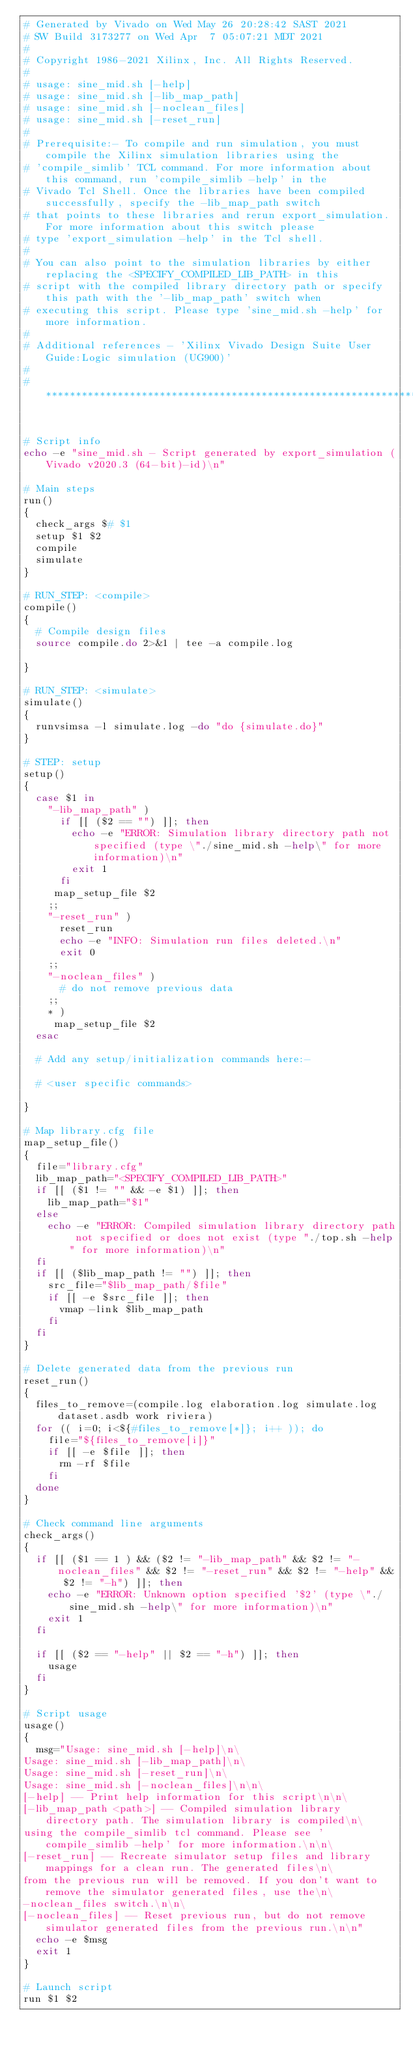Convert code to text. <code><loc_0><loc_0><loc_500><loc_500><_Bash_># Generated by Vivado on Wed May 26 20:28:42 SAST 2021
# SW Build 3173277 on Wed Apr  7 05:07:21 MDT 2021
#
# Copyright 1986-2021 Xilinx, Inc. All Rights Reserved. 
#
# usage: sine_mid.sh [-help]
# usage: sine_mid.sh [-lib_map_path]
# usage: sine_mid.sh [-noclean_files]
# usage: sine_mid.sh [-reset_run]
#
# Prerequisite:- To compile and run simulation, you must compile the Xilinx simulation libraries using the
# 'compile_simlib' TCL command. For more information about this command, run 'compile_simlib -help' in the
# Vivado Tcl Shell. Once the libraries have been compiled successfully, specify the -lib_map_path switch
# that points to these libraries and rerun export_simulation. For more information about this switch please
# type 'export_simulation -help' in the Tcl shell.
#
# You can also point to the simulation libraries by either replacing the <SPECIFY_COMPILED_LIB_PATH> in this
# script with the compiled library directory path or specify this path with the '-lib_map_path' switch when
# executing this script. Please type 'sine_mid.sh -help' for more information.
#
# Additional references - 'Xilinx Vivado Design Suite User Guide:Logic simulation (UG900)'
#
#*********************************************************************************************************


# Script info
echo -e "sine_mid.sh - Script generated by export_simulation (Vivado v2020.3 (64-bit)-id)\n"

# Main steps
run()
{
  check_args $# $1
  setup $1 $2
  compile
  simulate
}

# RUN_STEP: <compile>
compile()
{
  # Compile design files
  source compile.do 2>&1 | tee -a compile.log

}

# RUN_STEP: <simulate>
simulate()
{
  runvsimsa -l simulate.log -do "do {simulate.do}"
}

# STEP: setup
setup()
{
  case $1 in
    "-lib_map_path" )
      if [[ ($2 == "") ]]; then
        echo -e "ERROR: Simulation library directory path not specified (type \"./sine_mid.sh -help\" for more information)\n"
        exit 1
      fi
     map_setup_file $2
    ;;
    "-reset_run" )
      reset_run
      echo -e "INFO: Simulation run files deleted.\n"
      exit 0
    ;;
    "-noclean_files" )
      # do not remove previous data
    ;;
    * )
     map_setup_file $2
  esac

  # Add any setup/initialization commands here:-

  # <user specific commands>

}

# Map library.cfg file
map_setup_file()
{
  file="library.cfg"
  lib_map_path="<SPECIFY_COMPILED_LIB_PATH>"
  if [[ ($1 != "" && -e $1) ]]; then
    lib_map_path="$1"
  else
    echo -e "ERROR: Compiled simulation library directory path not specified or does not exist (type "./top.sh -help" for more information)\n"
  fi
  if [[ ($lib_map_path != "") ]]; then
    src_file="$lib_map_path/$file"
    if [[ -e $src_file ]]; then
      vmap -link $lib_map_path
    fi
  fi
}

# Delete generated data from the previous run
reset_run()
{
  files_to_remove=(compile.log elaboration.log simulate.log dataset.asdb work riviera)
  for (( i=0; i<${#files_to_remove[*]}; i++ )); do
    file="${files_to_remove[i]}"
    if [[ -e $file ]]; then
      rm -rf $file
    fi
  done
}

# Check command line arguments
check_args()
{
  if [[ ($1 == 1 ) && ($2 != "-lib_map_path" && $2 != "-noclean_files" && $2 != "-reset_run" && $2 != "-help" && $2 != "-h") ]]; then
    echo -e "ERROR: Unknown option specified '$2' (type \"./sine_mid.sh -help\" for more information)\n"
    exit 1
  fi

  if [[ ($2 == "-help" || $2 == "-h") ]]; then
    usage
  fi
}

# Script usage
usage()
{
  msg="Usage: sine_mid.sh [-help]\n\
Usage: sine_mid.sh [-lib_map_path]\n\
Usage: sine_mid.sh [-reset_run]\n\
Usage: sine_mid.sh [-noclean_files]\n\n\
[-help] -- Print help information for this script\n\n\
[-lib_map_path <path>] -- Compiled simulation library directory path. The simulation library is compiled\n\
using the compile_simlib tcl command. Please see 'compile_simlib -help' for more information.\n\n\
[-reset_run] -- Recreate simulator setup files and library mappings for a clean run. The generated files\n\
from the previous run will be removed. If you don't want to remove the simulator generated files, use the\n\
-noclean_files switch.\n\n\
[-noclean_files] -- Reset previous run, but do not remove simulator generated files from the previous run.\n\n"
  echo -e $msg
  exit 1
}

# Launch script
run $1 $2
</code> 